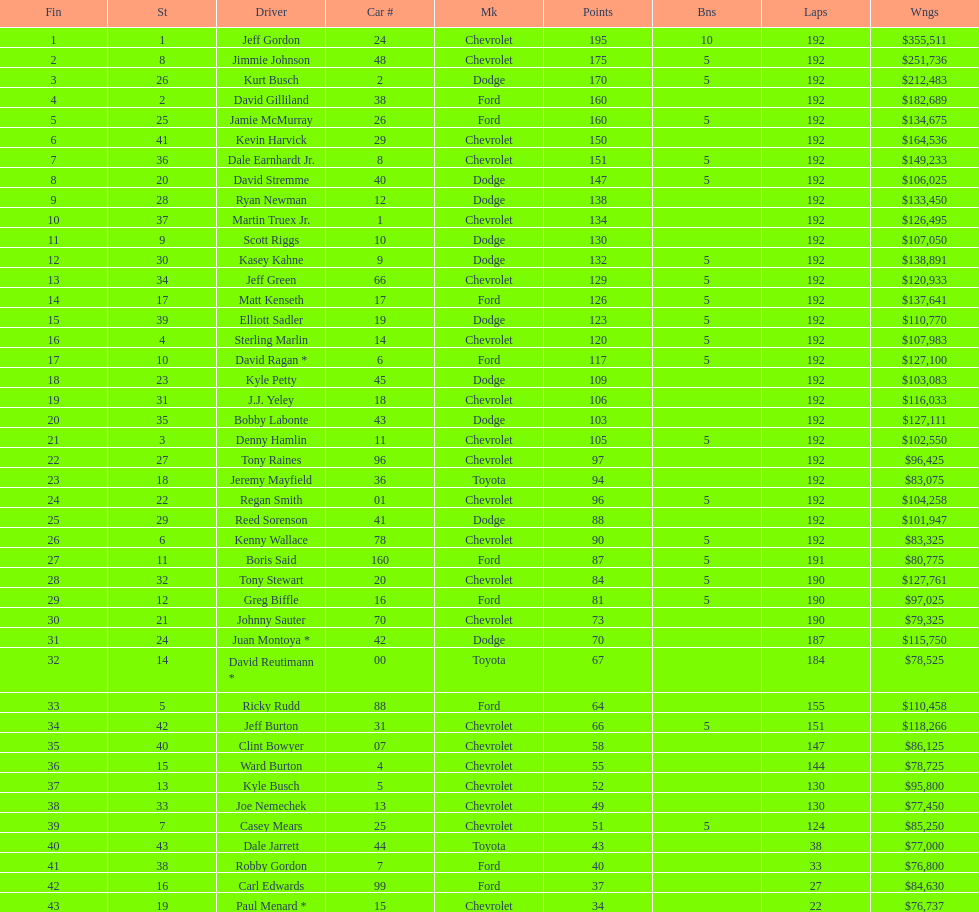What driver earned the least amount of winnings? Paul Menard *. 